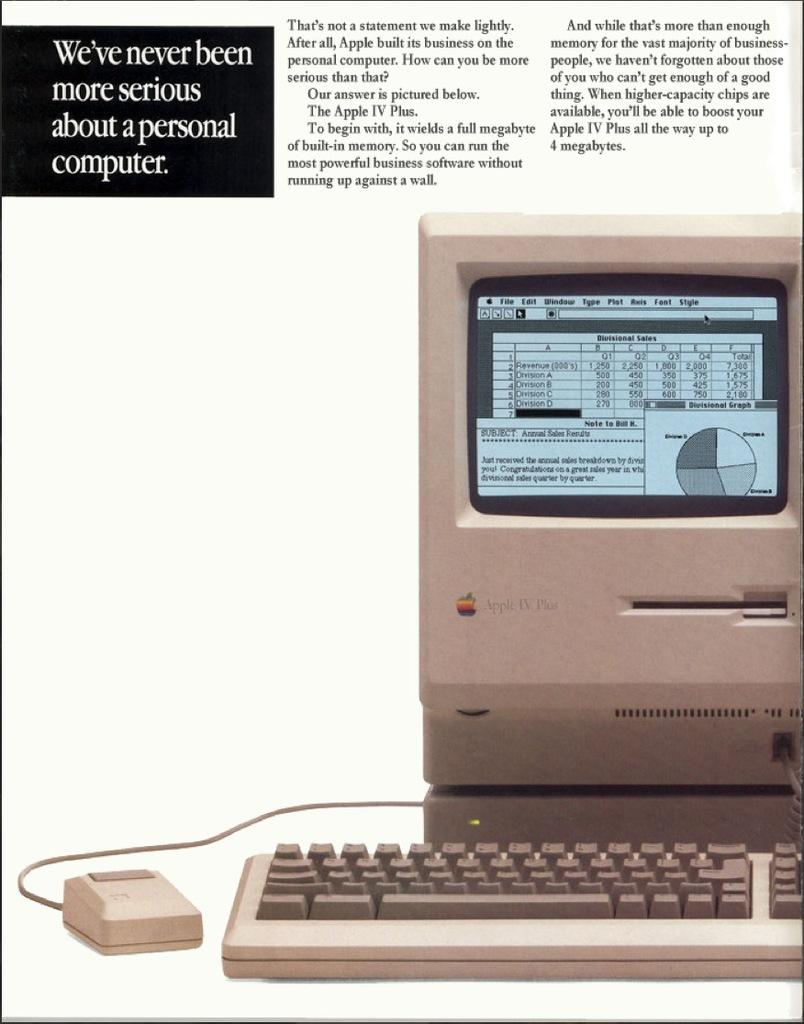Provide a one-sentence caption for the provided image. A ad for an old fashioned computer with the slogan 'we've never been more serious about a personal computer'. 